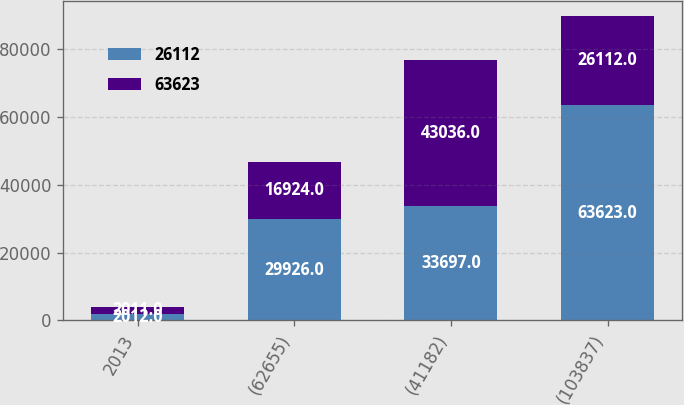<chart> <loc_0><loc_0><loc_500><loc_500><stacked_bar_chart><ecel><fcel>2013<fcel>(62655)<fcel>(41182)<fcel>(103837)<nl><fcel>26112<fcel>2012<fcel>29926<fcel>33697<fcel>63623<nl><fcel>63623<fcel>2011<fcel>16924<fcel>43036<fcel>26112<nl></chart> 